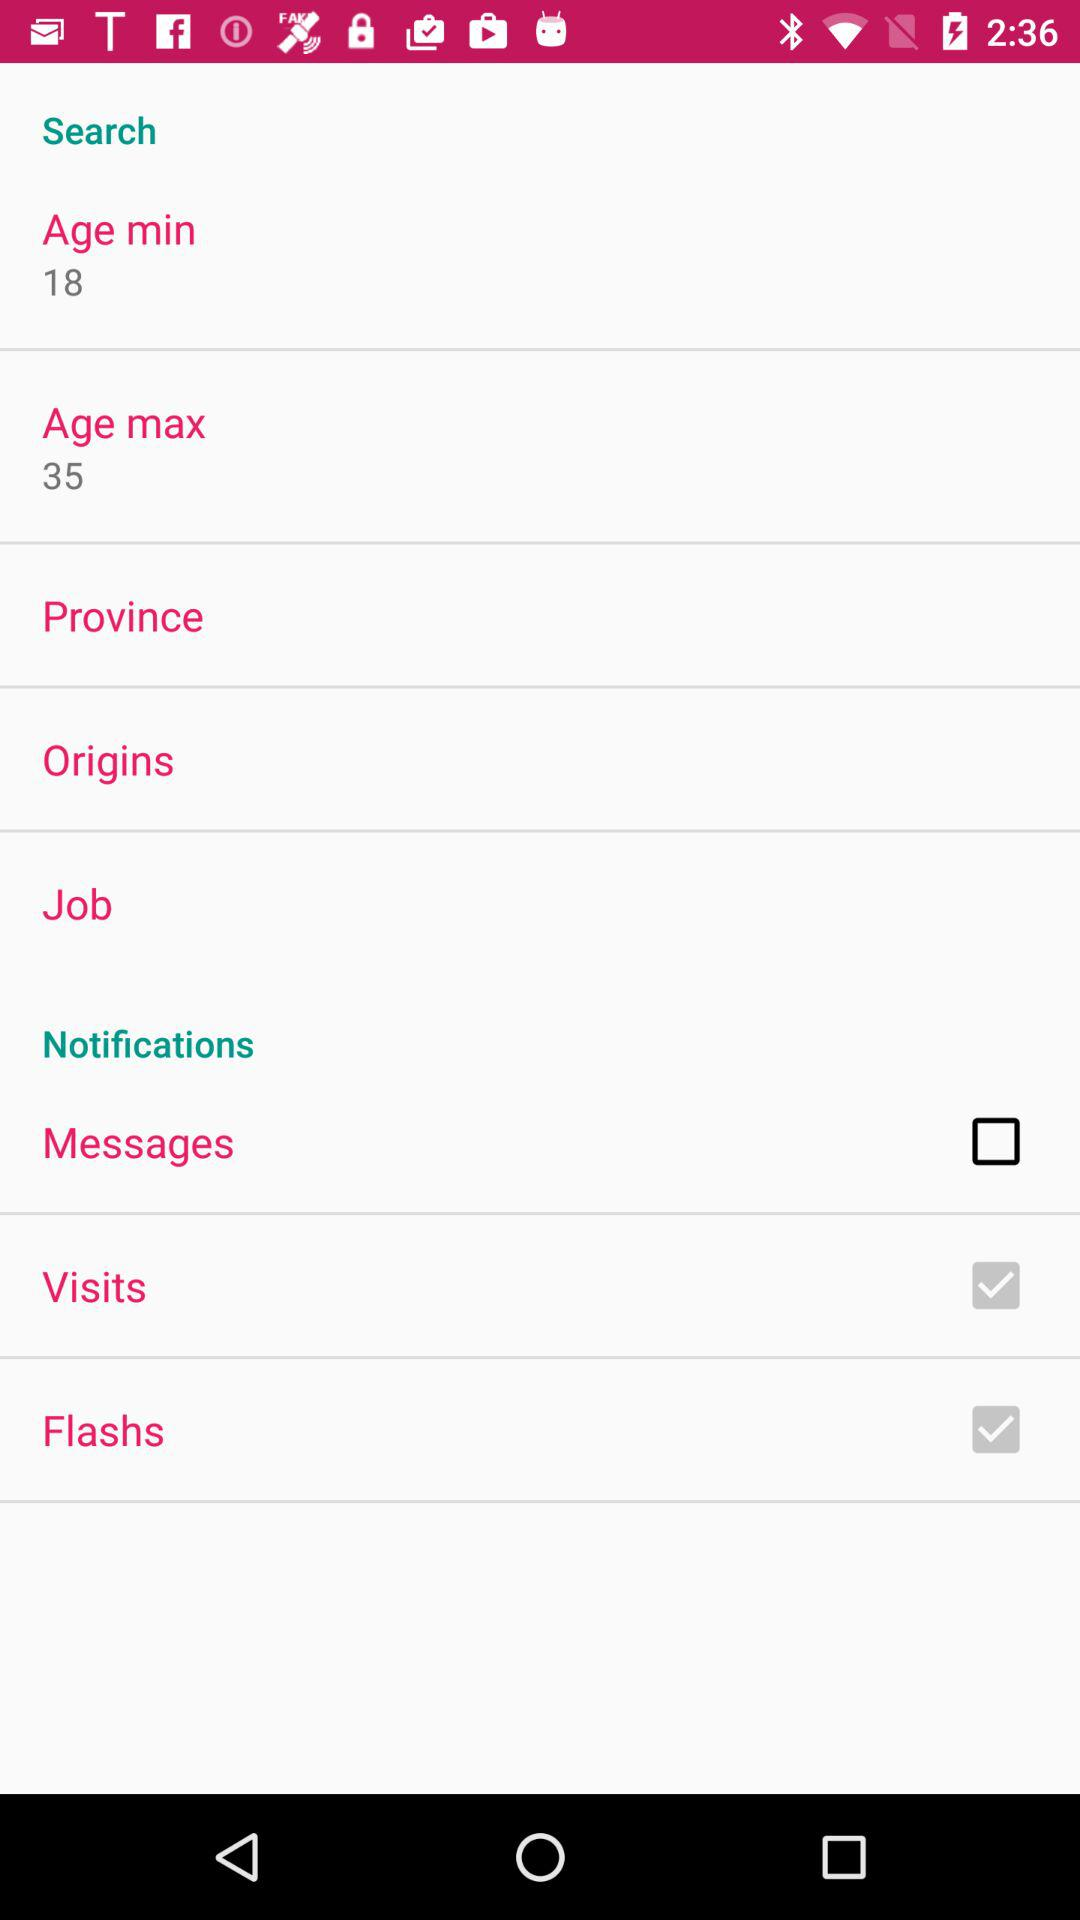What is the selected province?
When the provided information is insufficient, respond with <no answer>. <no answer> 